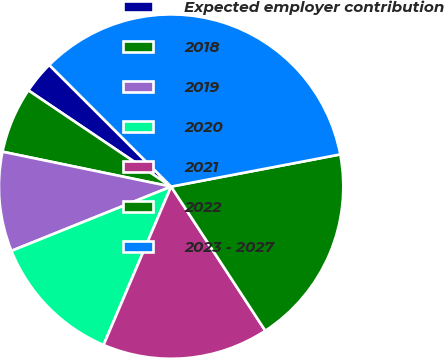Convert chart to OTSL. <chart><loc_0><loc_0><loc_500><loc_500><pie_chart><fcel>Expected employer contribution<fcel>2018<fcel>2019<fcel>2020<fcel>2021<fcel>2022<fcel>2023 - 2027<nl><fcel>3.05%<fcel>6.19%<fcel>9.34%<fcel>12.49%<fcel>15.63%<fcel>18.78%<fcel>34.52%<nl></chart> 